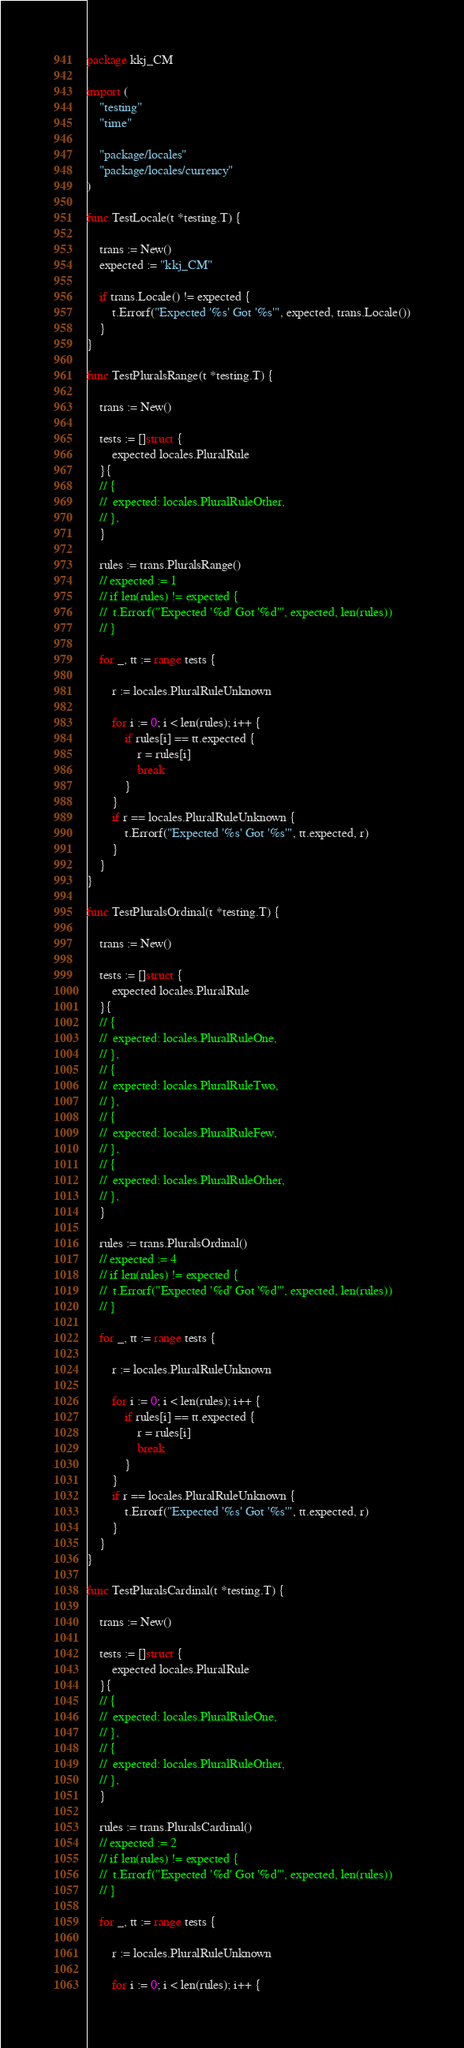<code> <loc_0><loc_0><loc_500><loc_500><_Go_>package kkj_CM

import (
	"testing"
	"time"

	"package/locales"
	"package/locales/currency"
)

func TestLocale(t *testing.T) {

	trans := New()
	expected := "kkj_CM"

	if trans.Locale() != expected {
		t.Errorf("Expected '%s' Got '%s'", expected, trans.Locale())
	}
}

func TestPluralsRange(t *testing.T) {

	trans := New()

	tests := []struct {
		expected locales.PluralRule
	}{
	// {
	// 	expected: locales.PluralRuleOther,
	// },
	}

	rules := trans.PluralsRange()
	// expected := 1
	// if len(rules) != expected {
	// 	t.Errorf("Expected '%d' Got '%d'", expected, len(rules))
	// }

	for _, tt := range tests {

		r := locales.PluralRuleUnknown

		for i := 0; i < len(rules); i++ {
			if rules[i] == tt.expected {
				r = rules[i]
				break
			}
		}
		if r == locales.PluralRuleUnknown {
			t.Errorf("Expected '%s' Got '%s'", tt.expected, r)
		}
	}
}

func TestPluralsOrdinal(t *testing.T) {

	trans := New()

	tests := []struct {
		expected locales.PluralRule
	}{
	// {
	// 	expected: locales.PluralRuleOne,
	// },
	// {
	// 	expected: locales.PluralRuleTwo,
	// },
	// {
	// 	expected: locales.PluralRuleFew,
	// },
	// {
	// 	expected: locales.PluralRuleOther,
	// },
	}

	rules := trans.PluralsOrdinal()
	// expected := 4
	// if len(rules) != expected {
	// 	t.Errorf("Expected '%d' Got '%d'", expected, len(rules))
	// }

	for _, tt := range tests {

		r := locales.PluralRuleUnknown

		for i := 0; i < len(rules); i++ {
			if rules[i] == tt.expected {
				r = rules[i]
				break
			}
		}
		if r == locales.PluralRuleUnknown {
			t.Errorf("Expected '%s' Got '%s'", tt.expected, r)
		}
	}
}

func TestPluralsCardinal(t *testing.T) {

	trans := New()

	tests := []struct {
		expected locales.PluralRule
	}{
	// {
	// 	expected: locales.PluralRuleOne,
	// },
	// {
	// 	expected: locales.PluralRuleOther,
	// },
	}

	rules := trans.PluralsCardinal()
	// expected := 2
	// if len(rules) != expected {
	// 	t.Errorf("Expected '%d' Got '%d'", expected, len(rules))
	// }

	for _, tt := range tests {

		r := locales.PluralRuleUnknown

		for i := 0; i < len(rules); i++ {</code> 